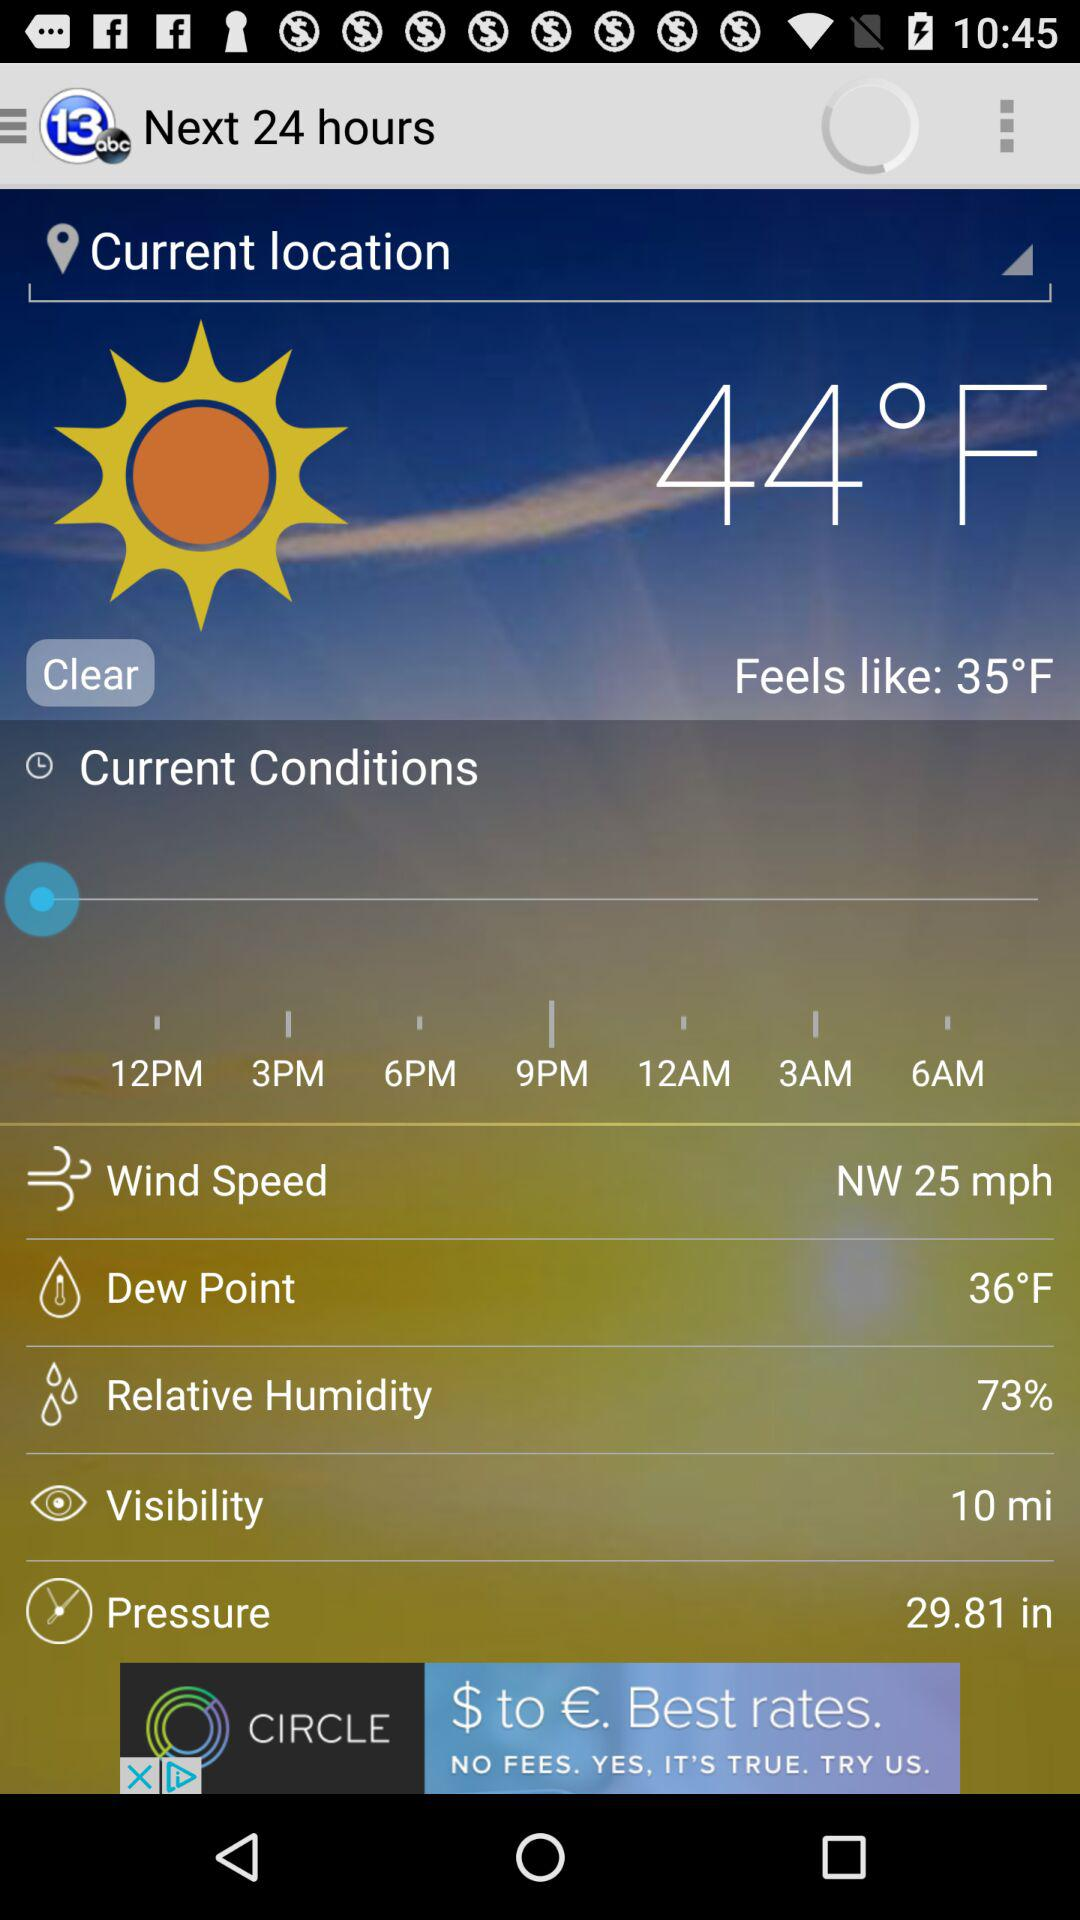What is the dew point? The dew point is 36 °F. 